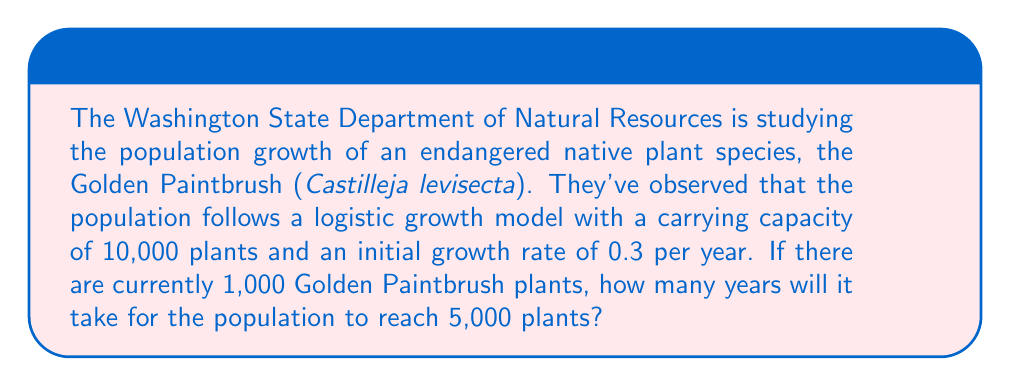Could you help me with this problem? Let's approach this step-by-step using the logistic growth model:

1) The logistic growth model is given by the equation:

   $$N(t) = \frac{K}{1 + (\frac{K}{N_0} - 1)e^{-rt}}$$

   Where:
   $N(t)$ is the population at time $t$
   $K$ is the carrying capacity
   $N_0$ is the initial population
   $r$ is the growth rate
   $t$ is the time

2) We're given:
   $K = 10,000$
   $N_0 = 1,000$
   $r = 0.3$
   $N(t) = 5,000$ (the population we want to reach)

3) Let's substitute these values into the equation:

   $$5000 = \frac{10000}{1 + (\frac{10000}{1000} - 1)e^{-0.3t}}$$

4) Simplify:
   $$5000 = \frac{10000}{1 + 9e^{-0.3t}}$$

5) Multiply both sides by $(1 + 9e^{-0.3t})$:
   $$5000(1 + 9e^{-0.3t}) = 10000$$

6) Expand:
   $$5000 + 45000e^{-0.3t} = 10000$$

7) Subtract 5000 from both sides:
   $$45000e^{-0.3t} = 5000$$

8) Divide both sides by 45000:
   $$e^{-0.3t} = \frac{1}{9}$$

9) Take the natural log of both sides:
   $$-0.3t = \ln(\frac{1}{9})$$

10) Divide both sides by -0.3:
    $$t = -\frac{\ln(\frac{1}{9})}{0.3} \approx 7.3$$

Therefore, it will take approximately 7.3 years for the Golden Paintbrush population to reach 5,000 plants.
Answer: 7.3 years 